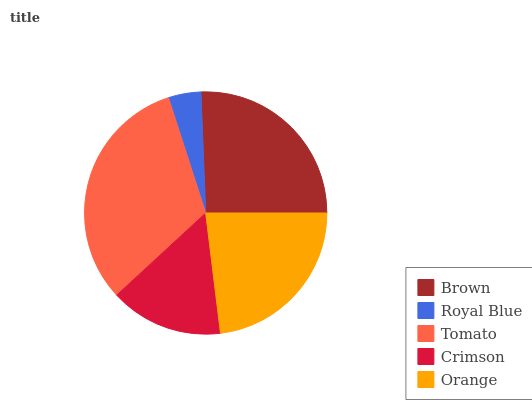Is Royal Blue the minimum?
Answer yes or no. Yes. Is Tomato the maximum?
Answer yes or no. Yes. Is Tomato the minimum?
Answer yes or no. No. Is Royal Blue the maximum?
Answer yes or no. No. Is Tomato greater than Royal Blue?
Answer yes or no. Yes. Is Royal Blue less than Tomato?
Answer yes or no. Yes. Is Royal Blue greater than Tomato?
Answer yes or no. No. Is Tomato less than Royal Blue?
Answer yes or no. No. Is Orange the high median?
Answer yes or no. Yes. Is Orange the low median?
Answer yes or no. Yes. Is Brown the high median?
Answer yes or no. No. Is Crimson the low median?
Answer yes or no. No. 